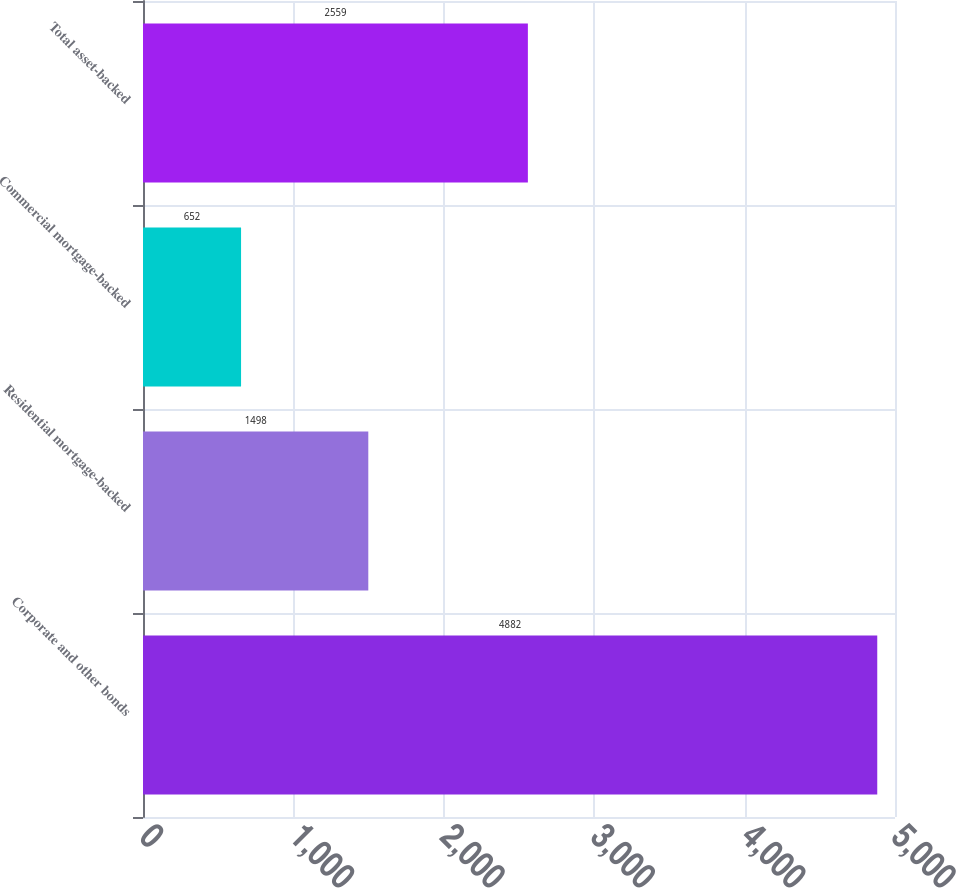Convert chart. <chart><loc_0><loc_0><loc_500><loc_500><bar_chart><fcel>Corporate and other bonds<fcel>Residential mortgage-backed<fcel>Commercial mortgage-backed<fcel>Total asset-backed<nl><fcel>4882<fcel>1498<fcel>652<fcel>2559<nl></chart> 